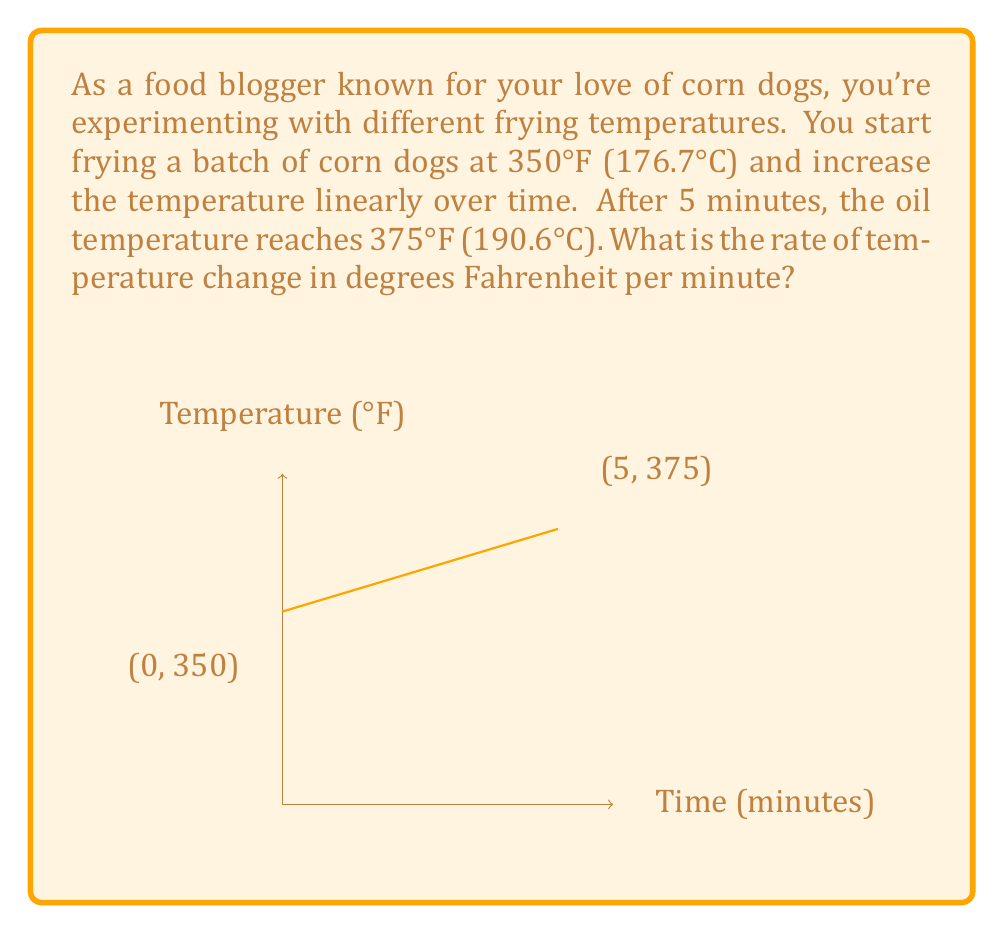Show me your answer to this math problem. To solve this problem, we need to calculate the rate of change of temperature with respect to time. Let's approach this step-by-step:

1) We have two points:
   At t = 0 minutes, T = 350°F
   At t = 5 minutes, T = 375°F

2) The rate of change is given by the slope of the line between these two points. We can use the slope formula:

   $$\text{Rate of change} = \frac{\text{Change in temperature}}{\text{Change in time}} = \frac{\Delta T}{\Delta t}$$

3) Let's plug in our values:

   $$\frac{\Delta T}{\Delta t} = \frac{375°F - 350°F}{5\text{ min} - 0\text{ min}} = \frac{25°F}{5\text{ min}}$$

4) Now, let's simplify:

   $$\frac{25°F}{5\text{ min}} = 5°F/\text{min}$$

Therefore, the temperature is increasing at a rate of 5°F per minute.
Answer: $5°F/\text{min}$ 